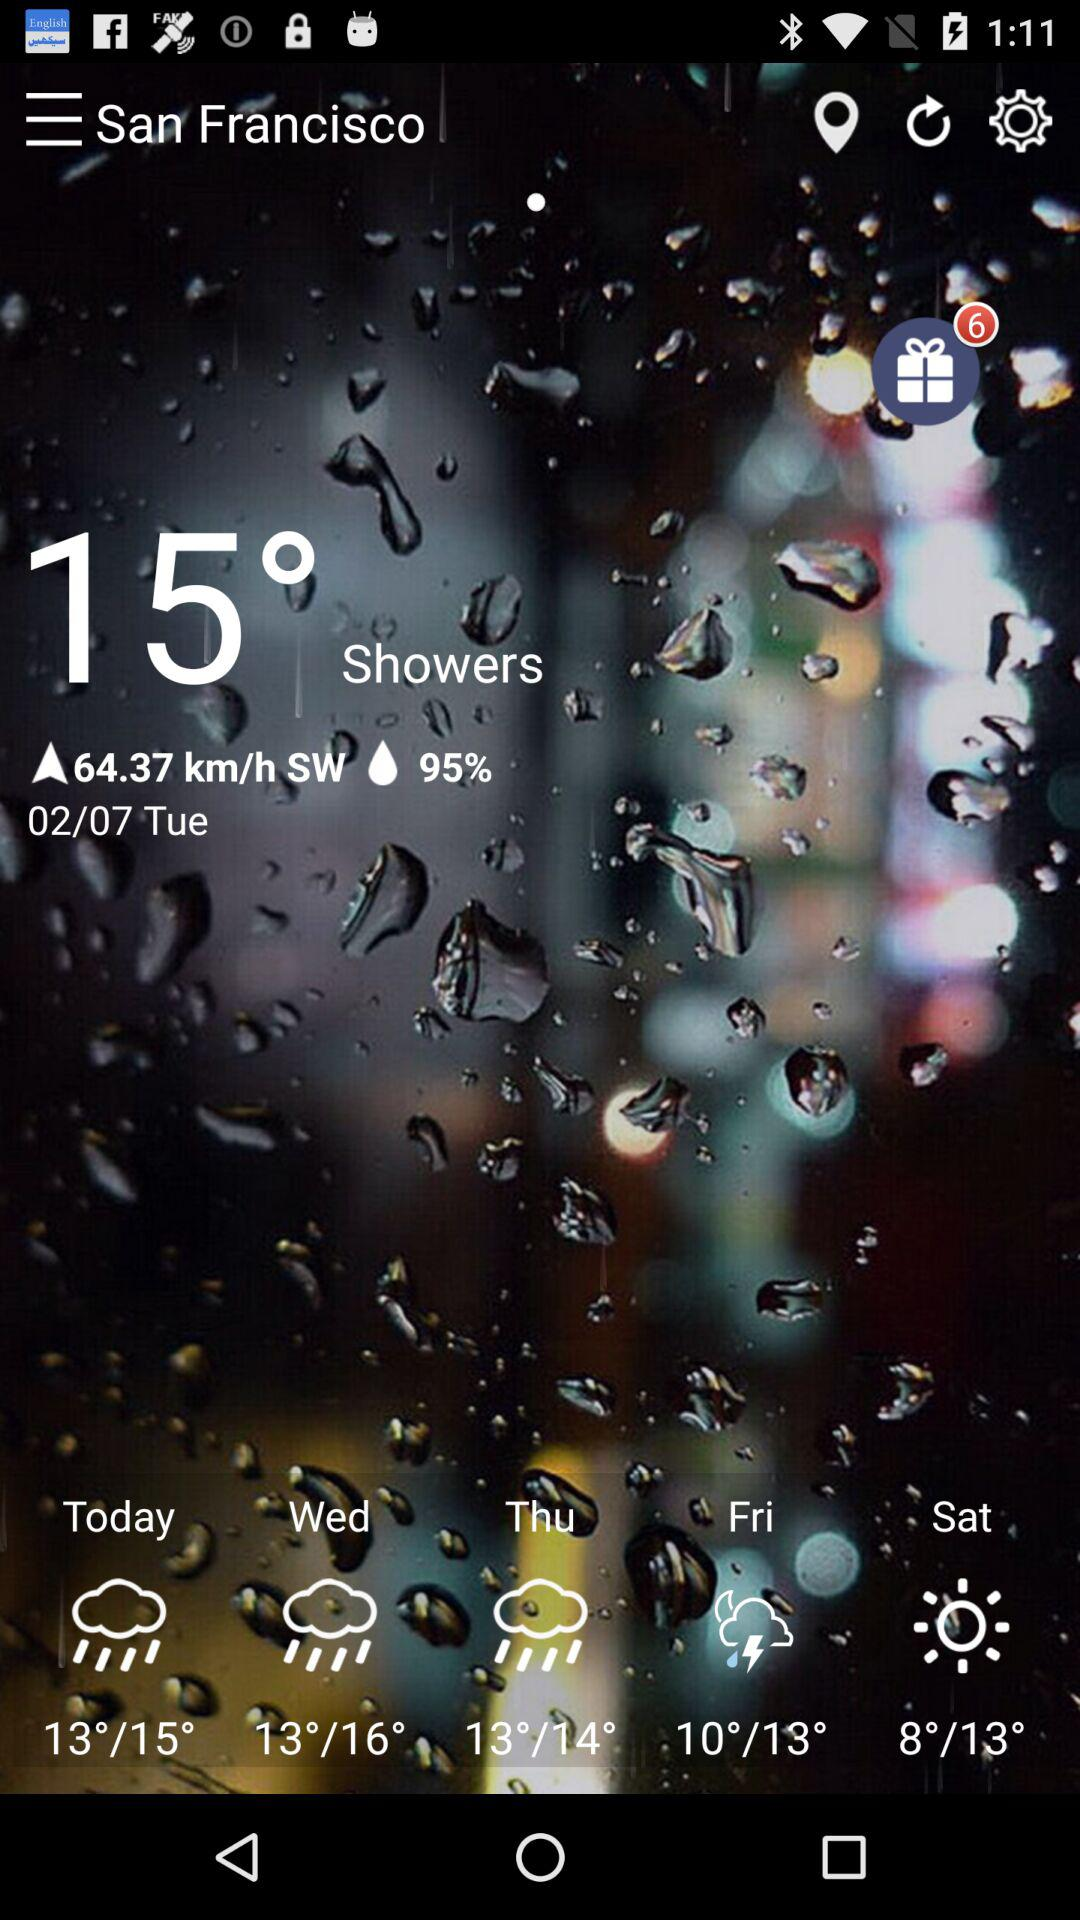What is the temperature? The temperature is 15°. 